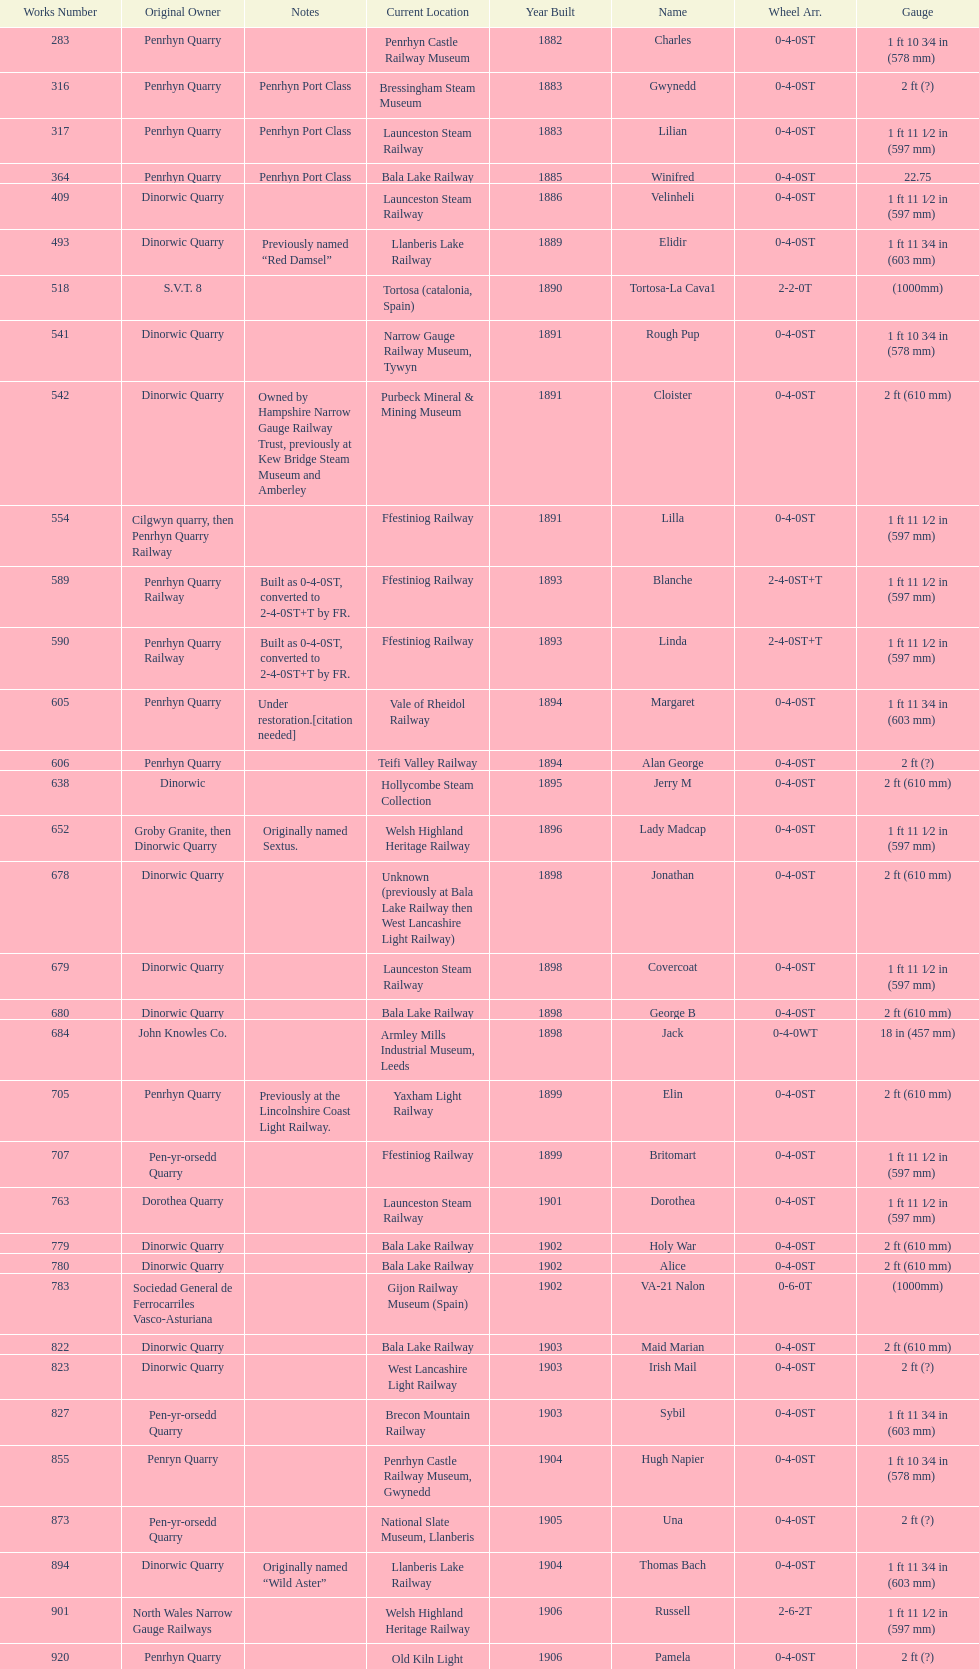Which original owner had the most locomotives? Penrhyn Quarry. 